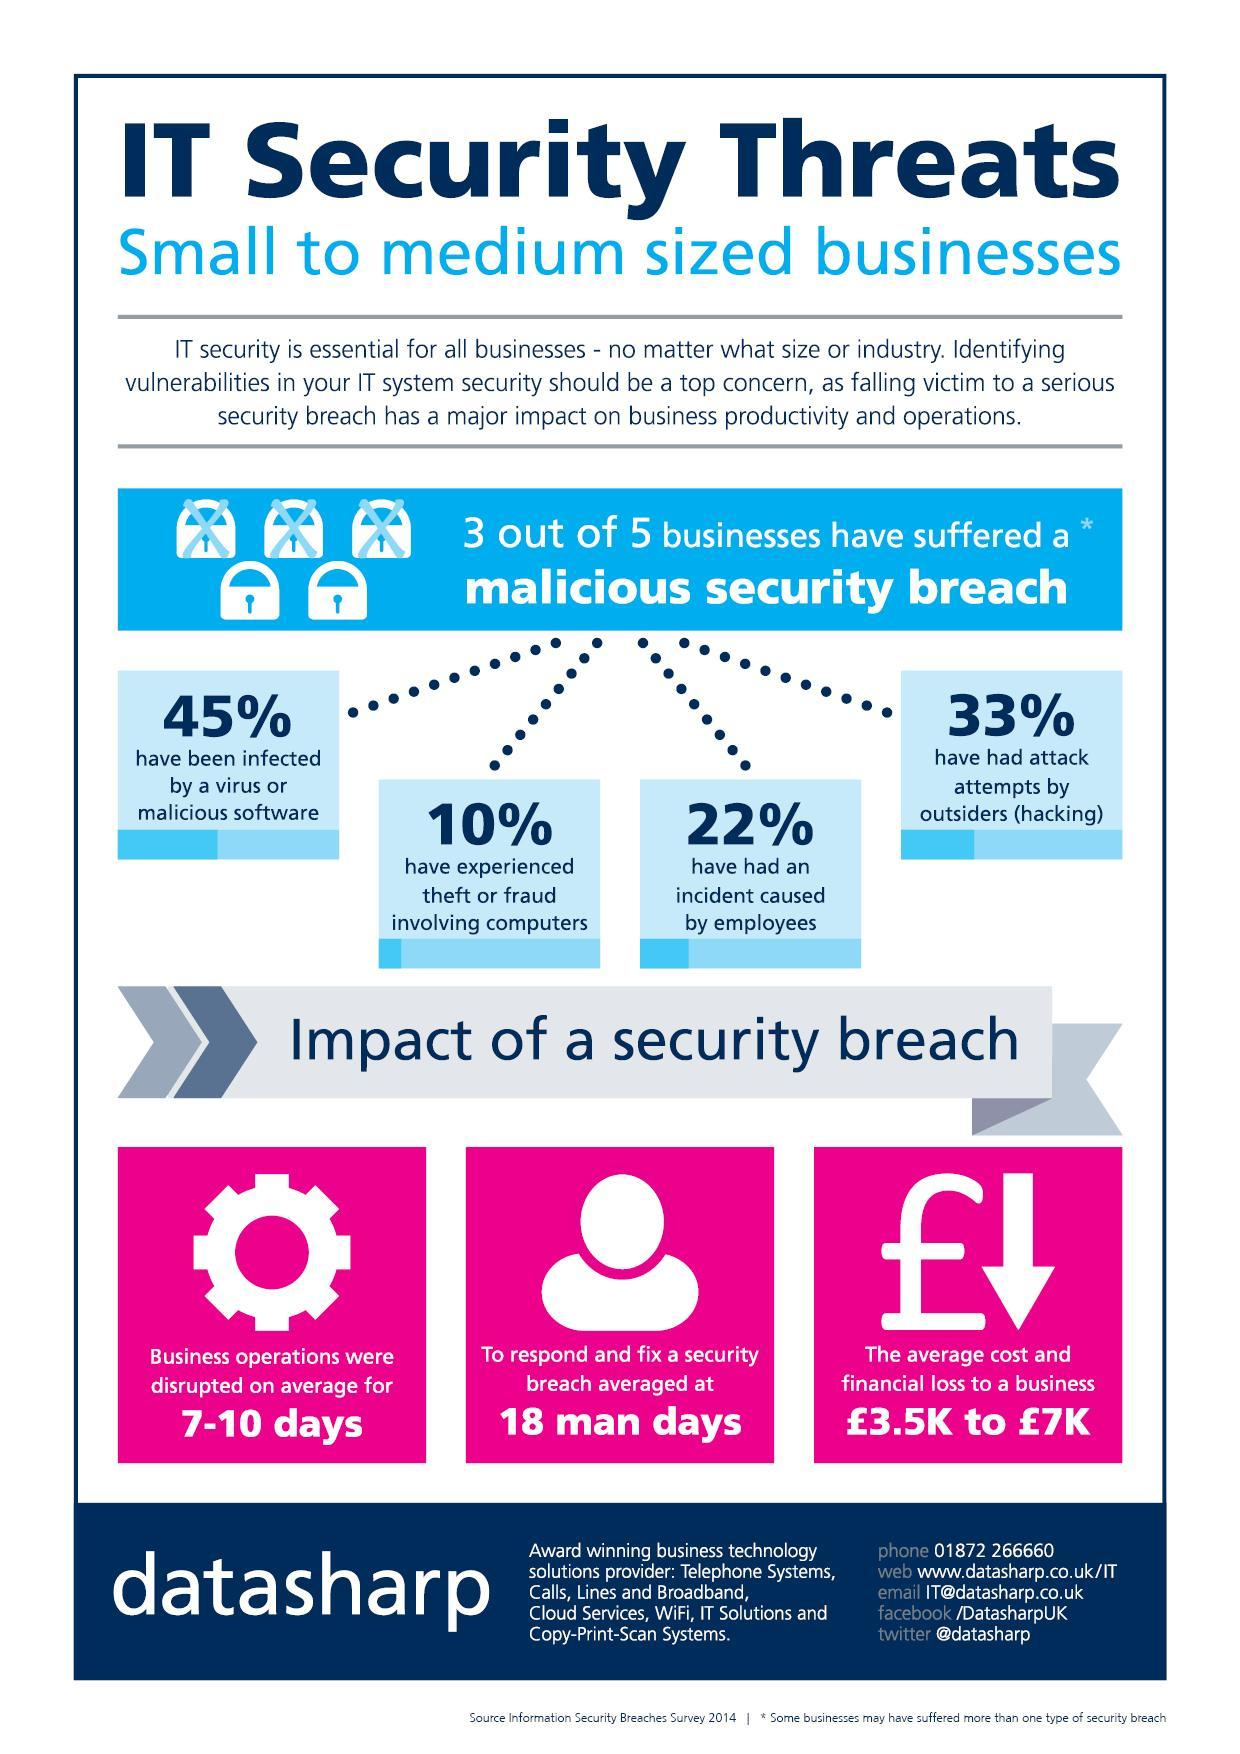What sort of malicious security breach is most experienced in businesses?
Answer the question with a short phrase. virus or malicious software What percentage of businesses have suffered a malicious security breach? 60% 